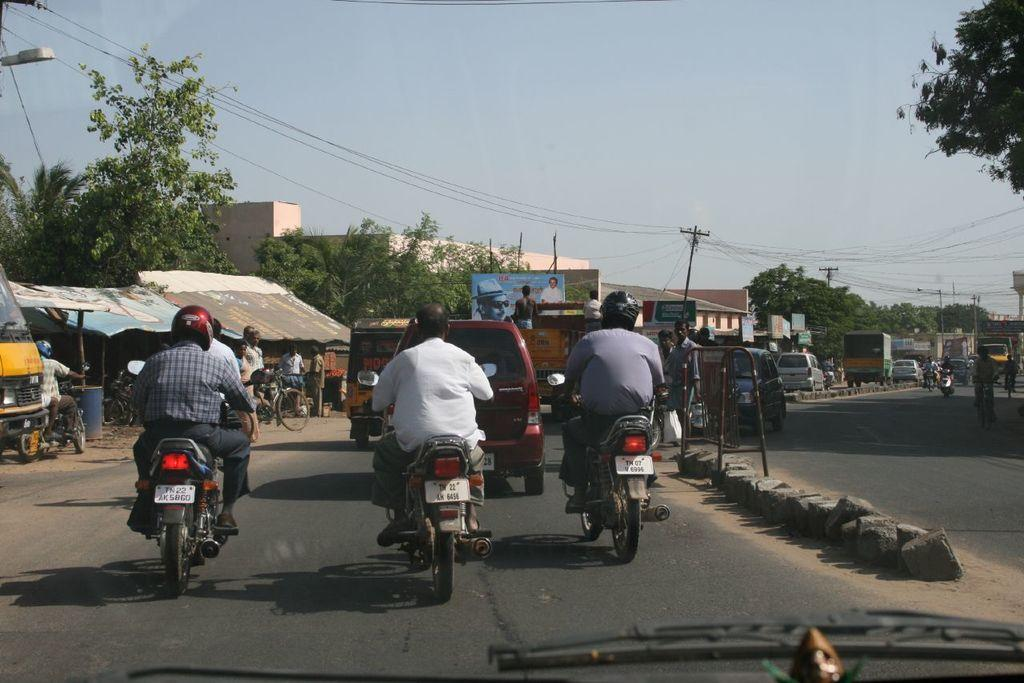How many persons are in the image? There are persons in the image. What are the persons doing in the image? The persons are on a vehicle. What is the vehicle located on? The vehicle is on a road. What other structures can be seen in the image? There are buildings in the image. What type of vegetation is present in the image? There are trees in the image. What is visible at the top of the image? The sky is visible at the top of the image. What is the texture of the debt in the image? There is no debt present in the image, and therefore no texture can be determined. 